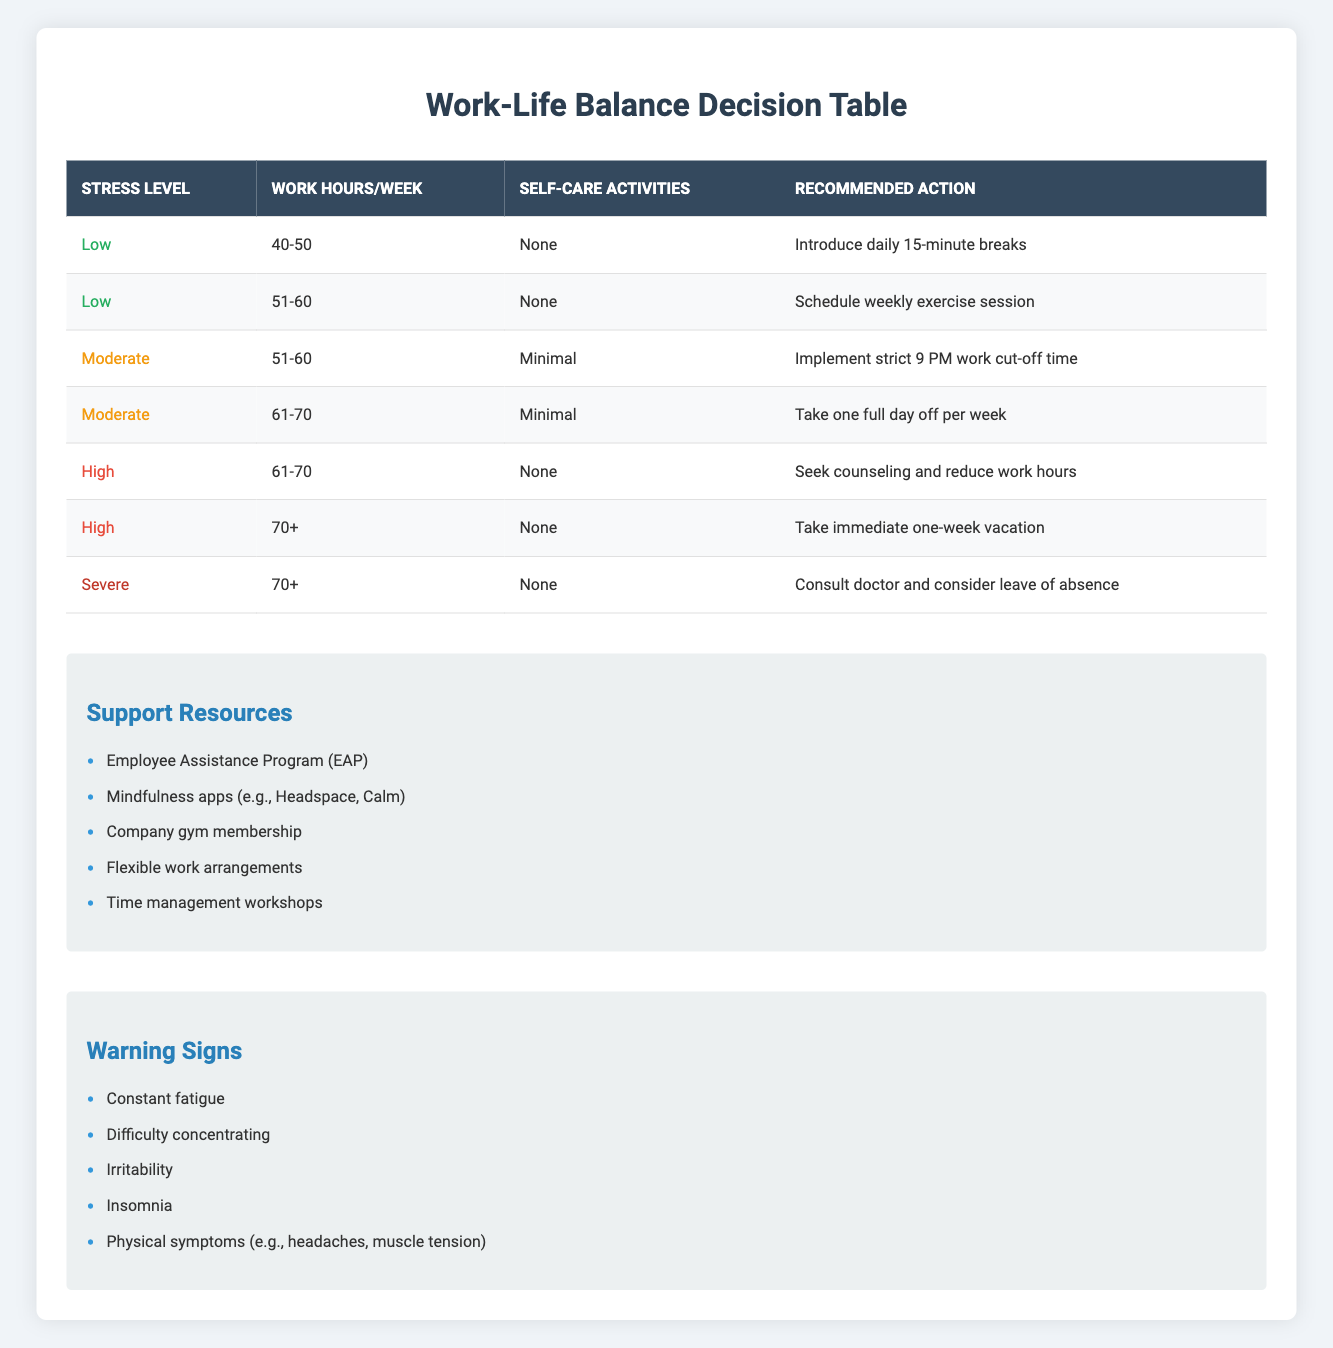What recommended action corresponds to a moderate stress level with 61-70 work hours and minimal self-care? From the table, I look for the entry with "Moderate" under the "Stress Level," "61-70" under "Work Hours/Week," and "Minimal" under "Self-Care Activities." The recommended action for this combination is "Take one full day off per week."
Answer: Take one full day off per week Is seeking counseling a recommended action for high stress with over 70 work hours? I check the rows with "High" for the stress level, looking specifically at 70+ hours. The action listed is "Take immediate one-week vacation." Therefore, seeking counseling isn't directly mentioned for "High" stress and "70+" hours.
Answer: No How many recommended actions are there for a low stress level? I count the entries in the table under "Stress Level" that list "Low." There are two recommended actions listed: "Introduce daily 15-minute breaks" and "Schedule weekly exercise session." So, the number is 2.
Answer: 2 What is the action suggested for someone with severe stress working over 70 hours and not engaging in self-care activities? I locate the entry that denotes "Severe" as the stress level, "70+" as the work hours, and "None" for self-care activities. The corresponding action is to "Consult doctor and consider leave of absence."
Answer: Consult doctor and consider leave of absence Are mindfulness apps mentioned as a support resource in the table? I refer to the section labeled "Support Resources" in the table to find if mindfulness apps are included. The list indeed mentions "Mindfulness apps (e.g., Headspace, Calm)."
Answer: Yes 